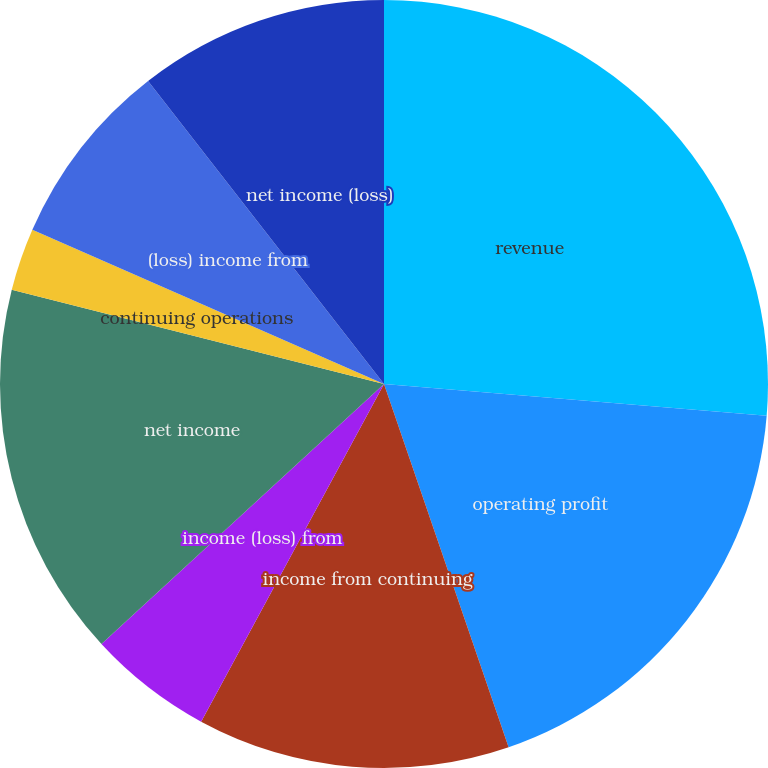Convert chart. <chart><loc_0><loc_0><loc_500><loc_500><pie_chart><fcel>revenue<fcel>operating profit<fcel>income from continuing<fcel>income (loss) from<fcel>net income<fcel>continuing operations<fcel>Discontinued operations<fcel>(loss) income from<fcel>net income (loss)<nl><fcel>26.32%<fcel>18.42%<fcel>13.16%<fcel>5.26%<fcel>15.79%<fcel>2.63%<fcel>0.0%<fcel>7.89%<fcel>10.53%<nl></chart> 